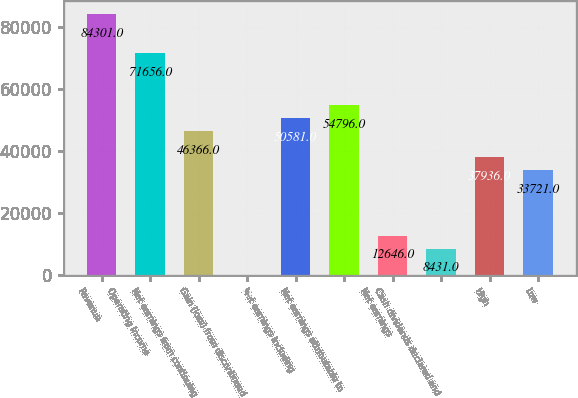Convert chart to OTSL. <chart><loc_0><loc_0><loc_500><loc_500><bar_chart><fcel>Revenue<fcel>Operating income<fcel>Net earnings from continuing<fcel>Gain (loss) from discontinued<fcel>Net earnings including<fcel>Net earnings attributable to<fcel>Net earnings<fcel>Cash dividends declared and<fcel>High<fcel>Low<nl><fcel>84301<fcel>71656<fcel>46366<fcel>1<fcel>50581<fcel>54796<fcel>12646<fcel>8431<fcel>37936<fcel>33721<nl></chart> 